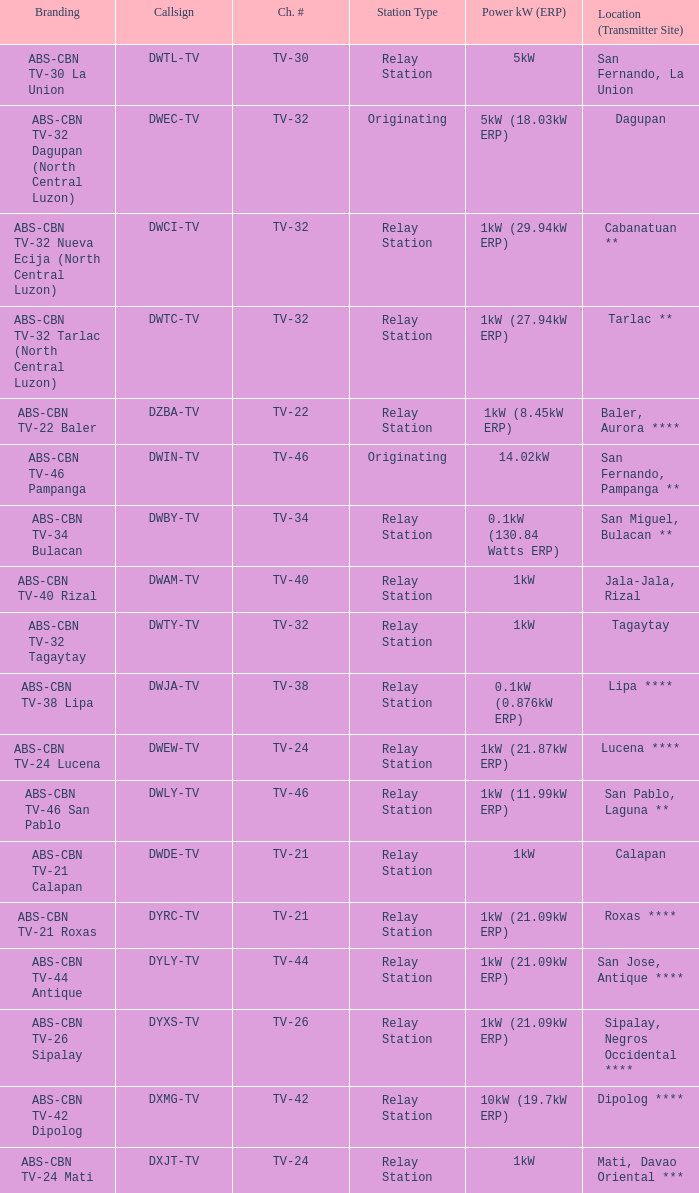94kw erp)? 1.0. 